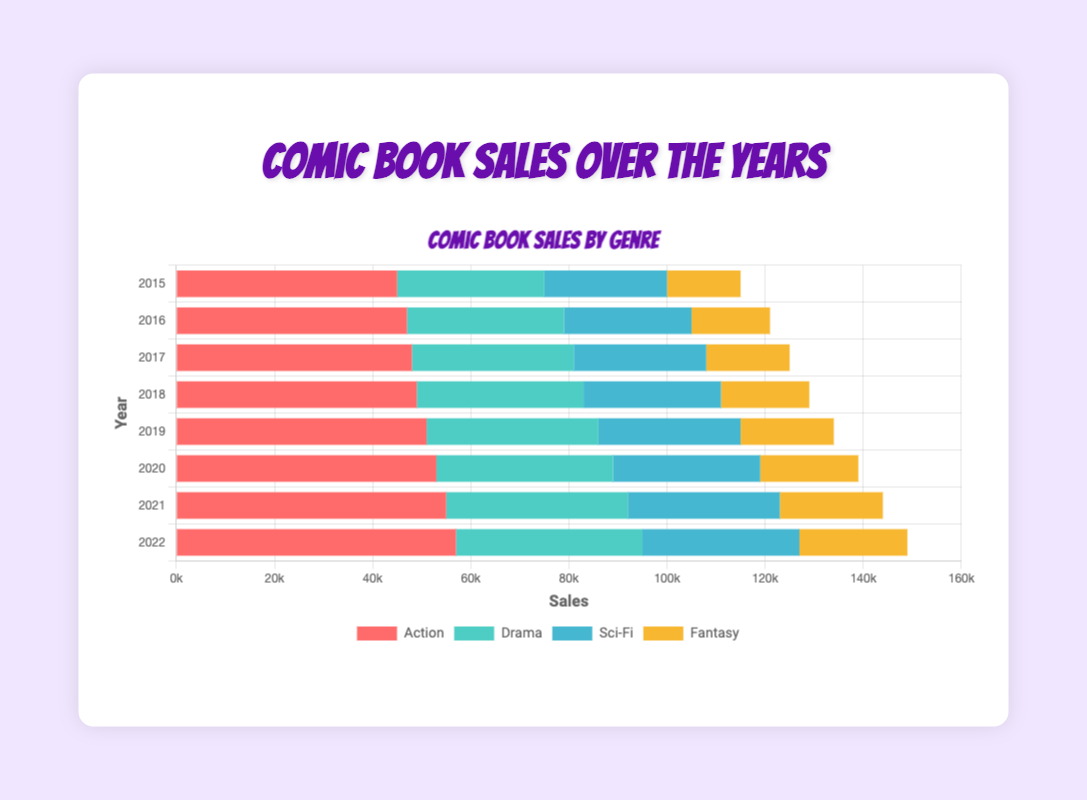Which year had the highest sales in the Action genre? Look for the longest bar part corresponding to the Action genre, which is visually represented in red, and note down the year on the y-axis.
Answer: 2022 Compare Sci-Fi sales in 2015 and 2022. Which year had higher sales and by how much? Identify the lengths of the Sci-Fi bars (blue) for 2015 and 2022. Subtract the smaller number from the larger one.
Answer: 2022, by 7000 What is the total sales of Drama comics over all the years combined? Sum up the values of the Drama genre (cyan) for each year.
Answer: 267000 Which genre had the least amount of sales in 2019? Identify the shortest bar segment for 2019 to find the genre with the lowest sales.
Answer: Fantasy How much did the sales of Fantasy comics increase from 2015 to 2022? Subtract the Fantasy sales amount in 2015 from the amount in 2022 to find the increase.
Answer: 7000 In which year did Drama comics experience its largest year-over-year increase in sales? Compare the increase in Drama sales (cyan) between each consecutive year and find the largest.
Answer: 2015 to 2016 Which genre consistently sold more than Sci-Fi from 2015 to 2022? Compare the lengths of the Action (red), Drama (cyan), and Fantasy (yellow) bars to the Sci-Fi (blue) bars for each year.
Answer: Action, Drama Is there any year where the total sales of Action and Fantasy genres are equal to or more than the total sales of Drama and Sci-Fi combined? Find the years where Action + Fantasy (red + yellow) is greater than or equal to Drama + Sci-Fi (cyan + blue).
Answer: No What is the average annual sales of Sci-Fi comics from 2015 to 2022? Sum the annual sales of Sci-Fi (blue) over the given years and divide by the number of years.
Answer: 28500 